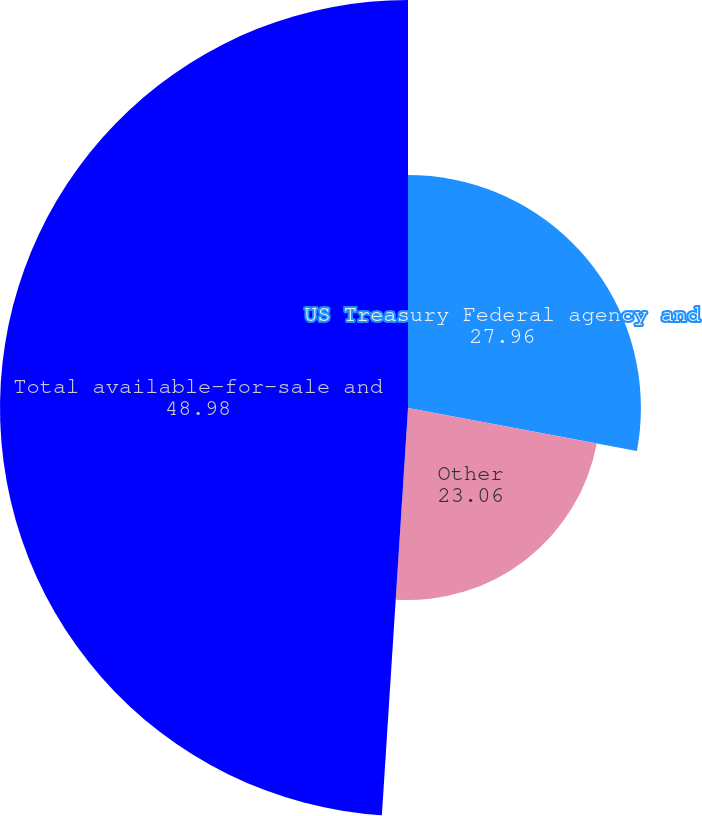<chart> <loc_0><loc_0><loc_500><loc_500><pie_chart><fcel>US Treasury Federal agency and<fcel>Other<fcel>Total available-for-sale and<fcel>Duration in years (1)<nl><fcel>27.96%<fcel>23.06%<fcel>48.98%<fcel>0.0%<nl></chart> 